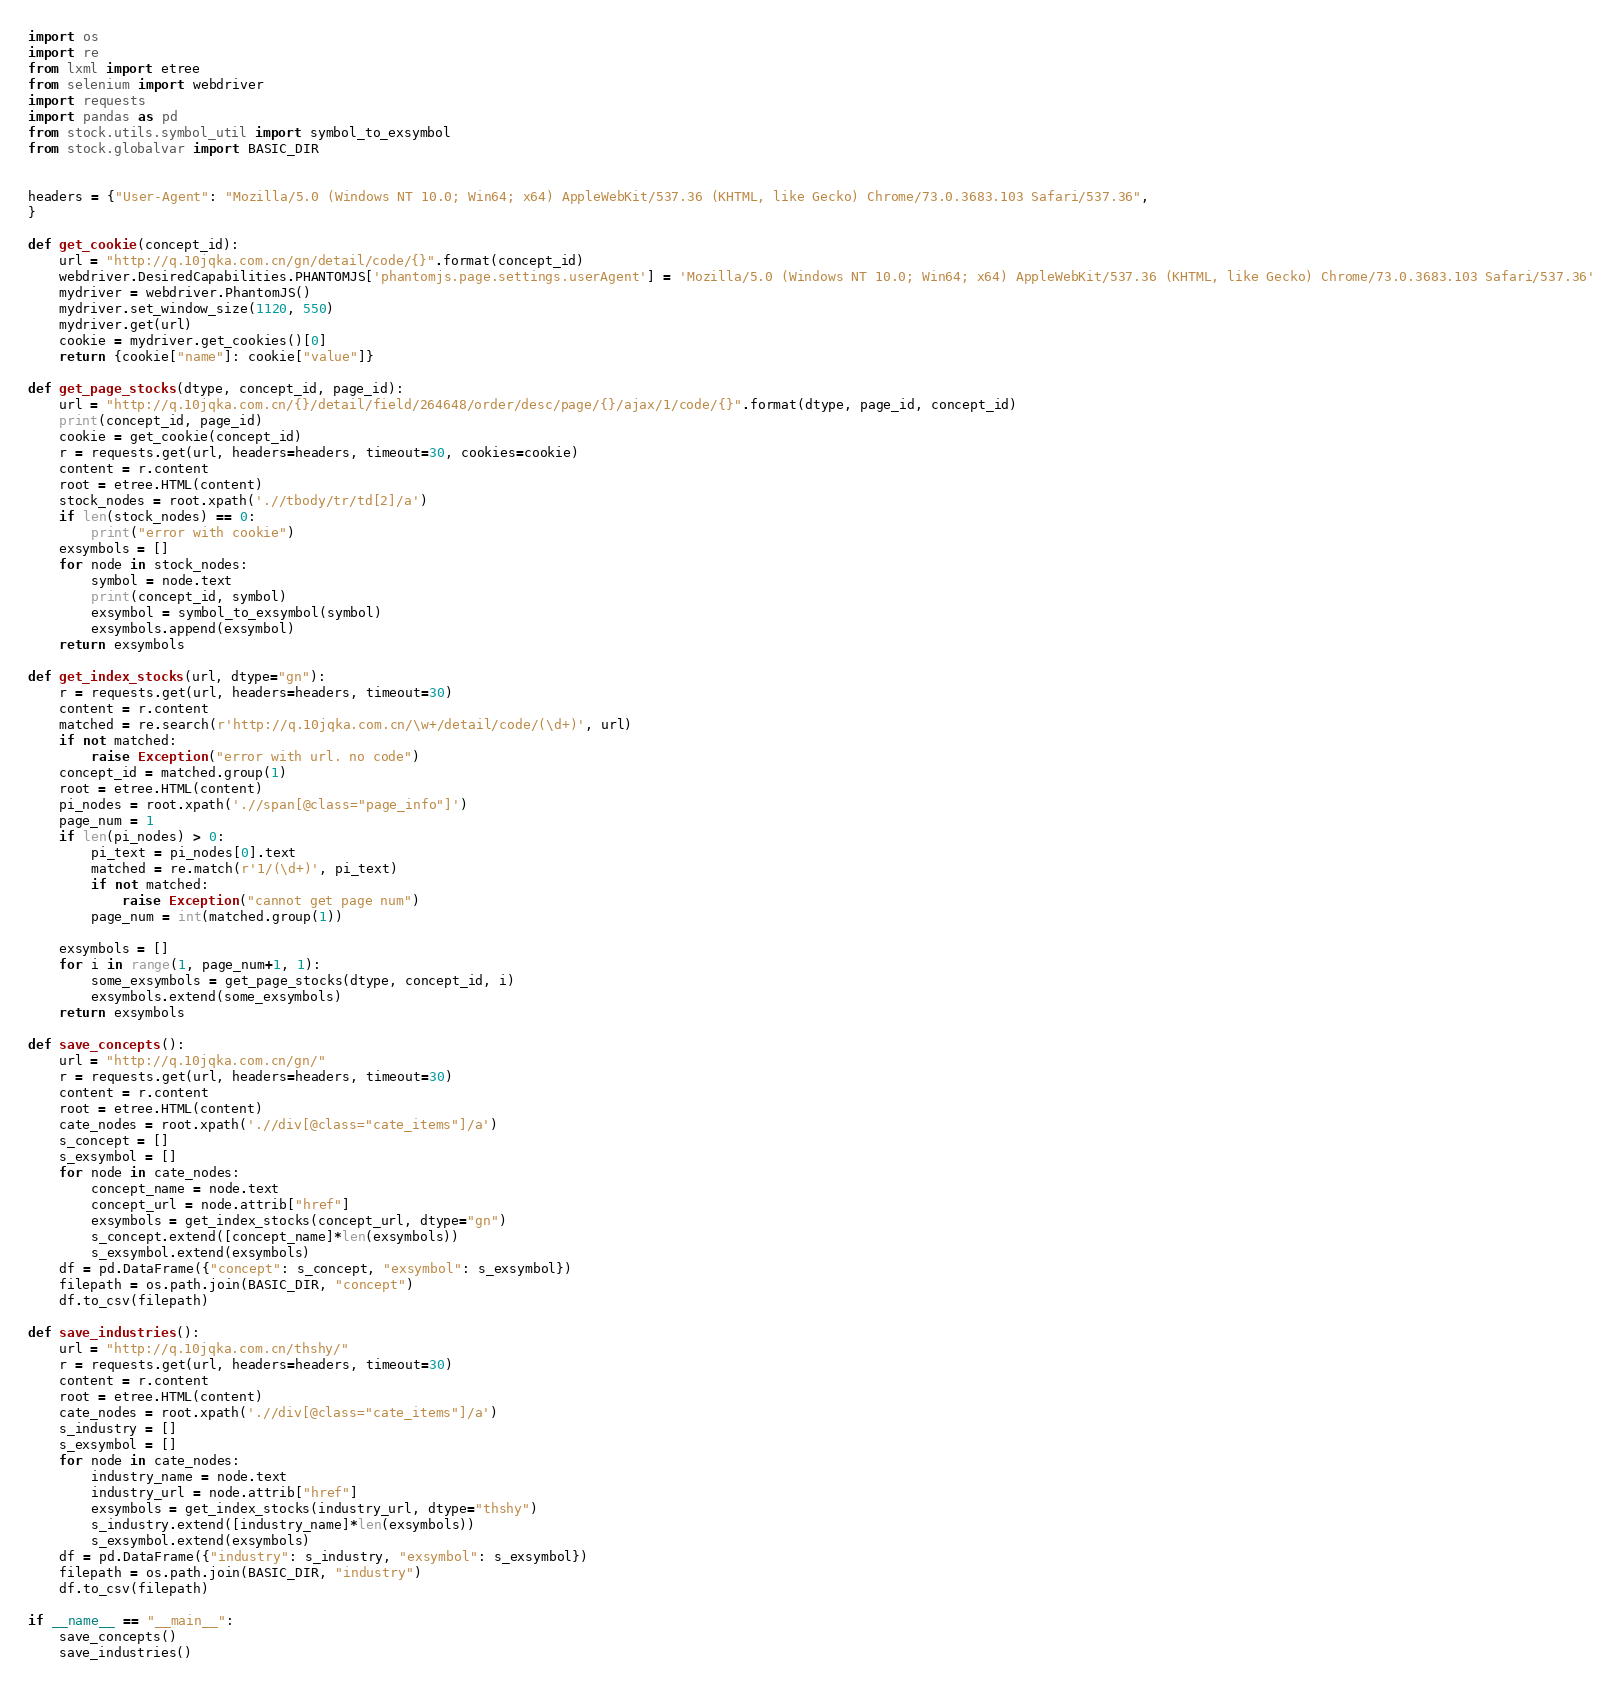Convert code to text. <code><loc_0><loc_0><loc_500><loc_500><_Python_>import os
import re
from lxml import etree
from selenium import webdriver
import requests
import pandas as pd
from stock.utils.symbol_util import symbol_to_exsymbol
from stock.globalvar import BASIC_DIR


headers = {"User-Agent": "Mozilla/5.0 (Windows NT 10.0; Win64; x64) AppleWebKit/537.36 (KHTML, like Gecko) Chrome/73.0.3683.103 Safari/537.36",
}

def get_cookie(concept_id):
    url = "http://q.10jqka.com.cn/gn/detail/code/{}".format(concept_id)
    webdriver.DesiredCapabilities.PHANTOMJS['phantomjs.page.settings.userAgent'] = 'Mozilla/5.0 (Windows NT 10.0; Win64; x64) AppleWebKit/537.36 (KHTML, like Gecko) Chrome/73.0.3683.103 Safari/537.36'
    mydriver = webdriver.PhantomJS()
    mydriver.set_window_size(1120, 550)
    mydriver.get(url)
    cookie = mydriver.get_cookies()[0]
    return {cookie["name"]: cookie["value"]}

def get_page_stocks(dtype, concept_id, page_id):
    url = "http://q.10jqka.com.cn/{}/detail/field/264648/order/desc/page/{}/ajax/1/code/{}".format(dtype, page_id, concept_id)
    print(concept_id, page_id)
    cookie = get_cookie(concept_id)
    r = requests.get(url, headers=headers, timeout=30, cookies=cookie)
    content = r.content
    root = etree.HTML(content)
    stock_nodes = root.xpath('.//tbody/tr/td[2]/a')
    if len(stock_nodes) == 0:
        print("error with cookie")
    exsymbols = []
    for node in stock_nodes:
        symbol = node.text
        print(concept_id, symbol)
        exsymbol = symbol_to_exsymbol(symbol)
        exsymbols.append(exsymbol)
    return exsymbols

def get_index_stocks(url, dtype="gn"):
    r = requests.get(url, headers=headers, timeout=30)
    content = r.content
    matched = re.search(r'http://q.10jqka.com.cn/\w+/detail/code/(\d+)', url)
    if not matched:
        raise Exception("error with url. no code")
    concept_id = matched.group(1)
    root = etree.HTML(content)
    pi_nodes = root.xpath('.//span[@class="page_info"]')
    page_num = 1
    if len(pi_nodes) > 0:
        pi_text = pi_nodes[0].text
        matched = re.match(r'1/(\d+)', pi_text)
        if not matched:
            raise Exception("cannot get page num")
        page_num = int(matched.group(1))

    exsymbols = []
    for i in range(1, page_num+1, 1):
        some_exsymbols = get_page_stocks(dtype, concept_id, i)
        exsymbols.extend(some_exsymbols)
    return exsymbols

def save_concepts():
    url = "http://q.10jqka.com.cn/gn/"
    r = requests.get(url, headers=headers, timeout=30)
    content = r.content
    root = etree.HTML(content)
    cate_nodes = root.xpath('.//div[@class="cate_items"]/a')
    s_concept = []
    s_exsymbol = []
    for node in cate_nodes:
        concept_name = node.text
        concept_url = node.attrib["href"]
        exsymbols = get_index_stocks(concept_url, dtype="gn")
        s_concept.extend([concept_name]*len(exsymbols))
        s_exsymbol.extend(exsymbols)
    df = pd.DataFrame({"concept": s_concept, "exsymbol": s_exsymbol})
    filepath = os.path.join(BASIC_DIR, "concept")
    df.to_csv(filepath)

def save_industries():
    url = "http://q.10jqka.com.cn/thshy/"
    r = requests.get(url, headers=headers, timeout=30)
    content = r.content
    root = etree.HTML(content)
    cate_nodes = root.xpath('.//div[@class="cate_items"]/a')
    s_industry = []
    s_exsymbol = []
    for node in cate_nodes:
        industry_name = node.text
        industry_url = node.attrib["href"]
        exsymbols = get_index_stocks(industry_url, dtype="thshy")
        s_industry.extend([industry_name]*len(exsymbols))
        s_exsymbol.extend(exsymbols)
    df = pd.DataFrame({"industry": s_industry, "exsymbol": s_exsymbol})
    filepath = os.path.join(BASIC_DIR, "industry")
    df.to_csv(filepath)

if __name__ == "__main__":
    save_concepts()
    save_industries()
</code> 